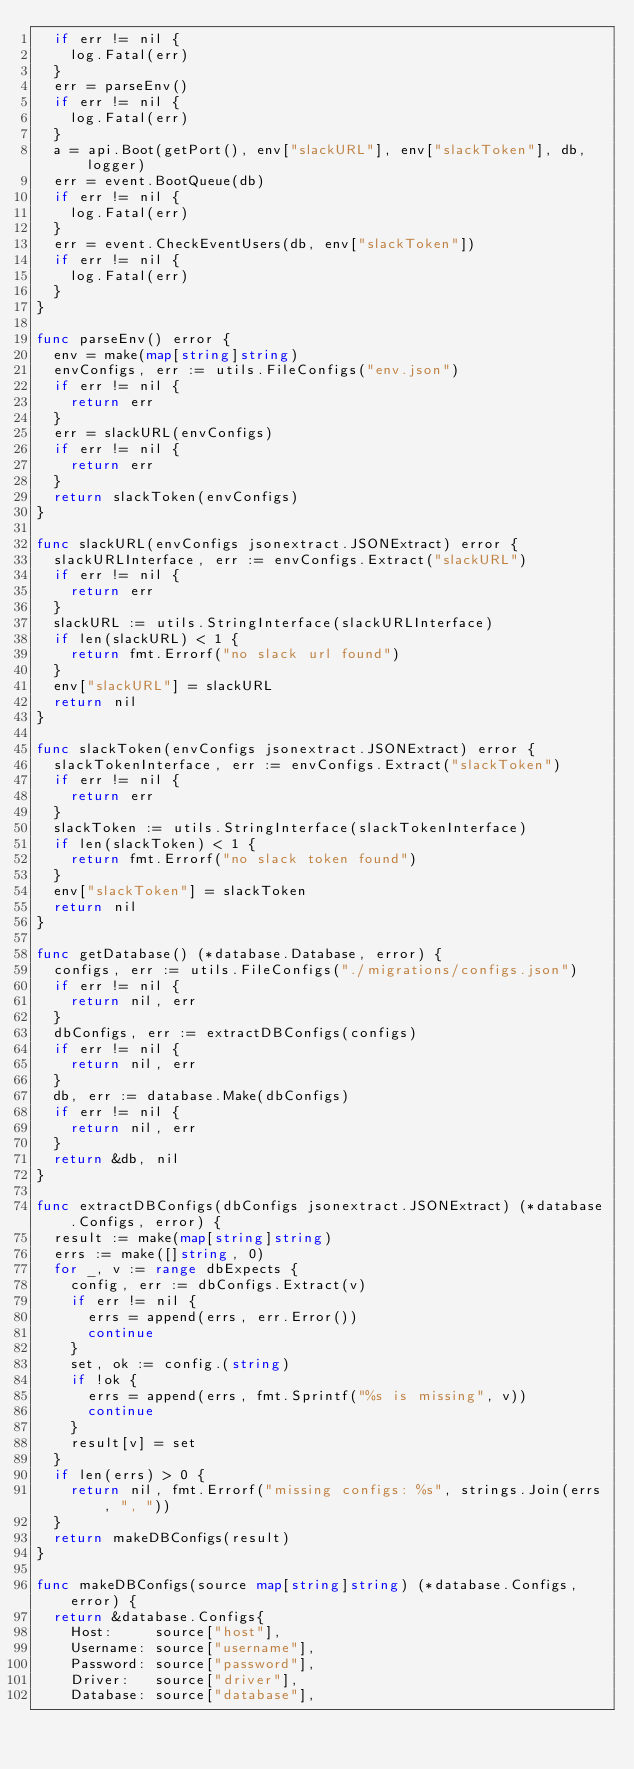Convert code to text. <code><loc_0><loc_0><loc_500><loc_500><_Go_>	if err != nil {
		log.Fatal(err)
	}
	err = parseEnv()
	if err != nil {
		log.Fatal(err)
	}
	a = api.Boot(getPort(), env["slackURL"], env["slackToken"], db, logger)
	err = event.BootQueue(db)
	if err != nil {
		log.Fatal(err)
	}
	err = event.CheckEventUsers(db, env["slackToken"])
	if err != nil {
		log.Fatal(err)
	}
}

func parseEnv() error {
	env = make(map[string]string)
	envConfigs, err := utils.FileConfigs("env.json")
	if err != nil {
		return err
	}
	err = slackURL(envConfigs)
	if err != nil {
		return err
	}
	return slackToken(envConfigs)
}

func slackURL(envConfigs jsonextract.JSONExtract) error {
	slackURLInterface, err := envConfigs.Extract("slackURL")
	if err != nil {
		return err
	}
	slackURL := utils.StringInterface(slackURLInterface)
	if len(slackURL) < 1 {
		return fmt.Errorf("no slack url found")
	}
	env["slackURL"] = slackURL
	return nil
}

func slackToken(envConfigs jsonextract.JSONExtract) error {
	slackTokenInterface, err := envConfigs.Extract("slackToken")
	if err != nil {
		return err
	}
	slackToken := utils.StringInterface(slackTokenInterface)
	if len(slackToken) < 1 {
		return fmt.Errorf("no slack token found")
	}
	env["slackToken"] = slackToken
	return nil
}

func getDatabase() (*database.Database, error) {
	configs, err := utils.FileConfigs("./migrations/configs.json")
	if err != nil {
		return nil, err
	}
	dbConfigs, err := extractDBConfigs(configs)
	if err != nil {
		return nil, err
	}
	db, err := database.Make(dbConfigs)
	if err != nil {
		return nil, err
	}
	return &db, nil
}

func extractDBConfigs(dbConfigs jsonextract.JSONExtract) (*database.Configs, error) {
	result := make(map[string]string)
	errs := make([]string, 0)
	for _, v := range dbExpects {
		config, err := dbConfigs.Extract(v)
		if err != nil {
			errs = append(errs, err.Error())
			continue
		}
		set, ok := config.(string)
		if !ok {
			errs = append(errs, fmt.Sprintf("%s is missing", v))
			continue
		}
		result[v] = set
	}
	if len(errs) > 0 {
		return nil, fmt.Errorf("missing configs: %s", strings.Join(errs, ", "))
	}
	return makeDBConfigs(result)
}

func makeDBConfigs(source map[string]string) (*database.Configs, error) {
	return &database.Configs{
		Host:     source["host"],
		Username: source["username"],
		Password: source["password"],
		Driver:   source["driver"],
		Database: source["database"],</code> 